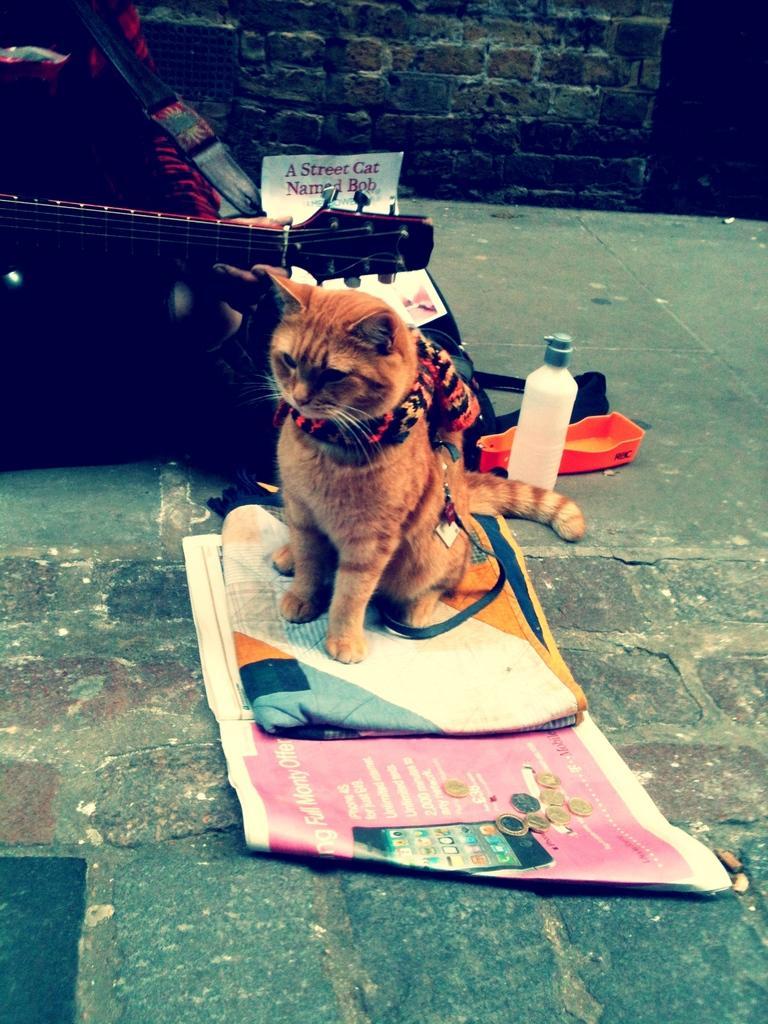How would you summarize this image in a sentence or two? In this picture, we see the cat is on the blanket and the banner which is in pink color. We see the coins are placed on the banner. On the left side, we see a person in the red dress is holding a guitar in his hands and he might be playing it. Behind the cat, we see a water bottle, box in orange color and a paper. In the background, we see a wall which is made up of stones. 